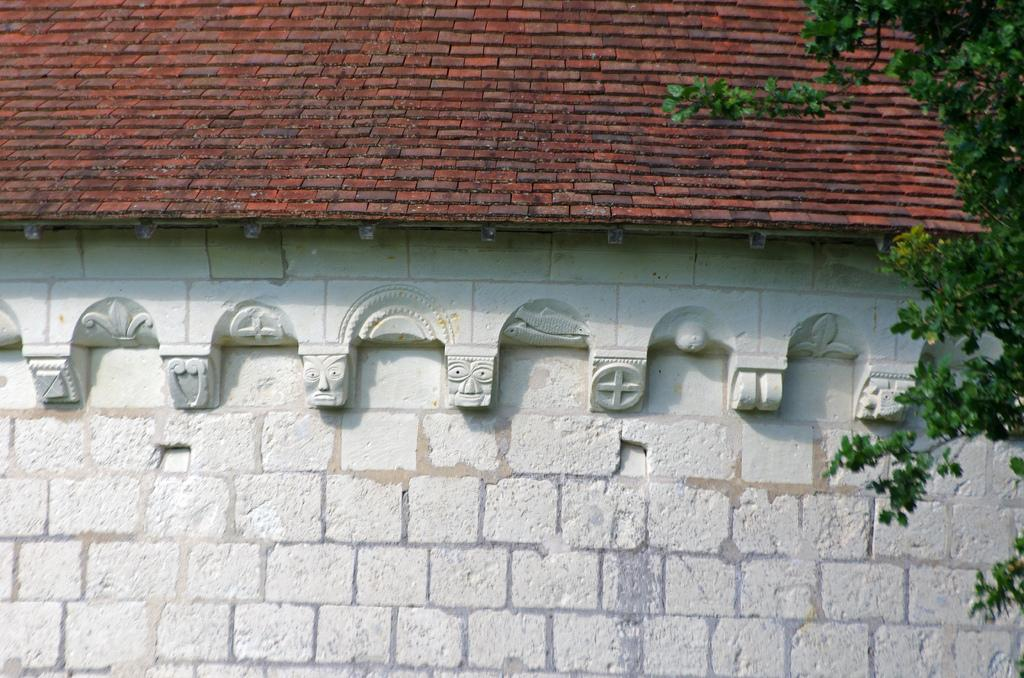What type of structure is shown in the image? The image is of a building. What can be seen on the top of the building? There are roof tiles on the top of the building. What is located on the right side of the image? There is a tree on the right side of the image. How many people are pushing the building out of the quicksand in the image? There is no quicksand or people pushing the building in the image; it is a static image of a building with roof tiles and a tree on the right side. 